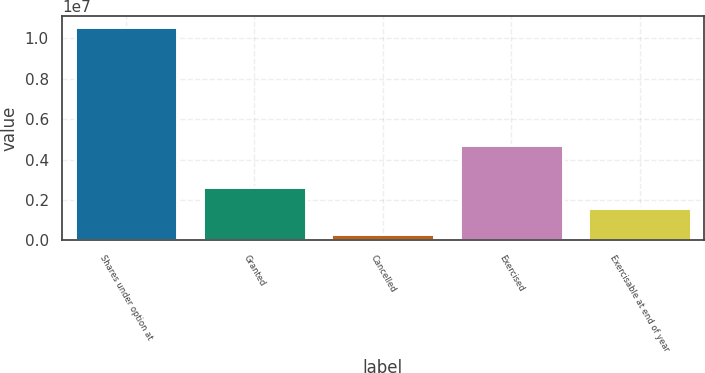<chart> <loc_0><loc_0><loc_500><loc_500><bar_chart><fcel>Shares under option at<fcel>Granted<fcel>Cancelled<fcel>Exercised<fcel>Exercisable at end of year<nl><fcel>1.05599e+07<fcel>2.6452e+06<fcel>301608<fcel>4.73572e+06<fcel>1.61937e+06<nl></chart> 